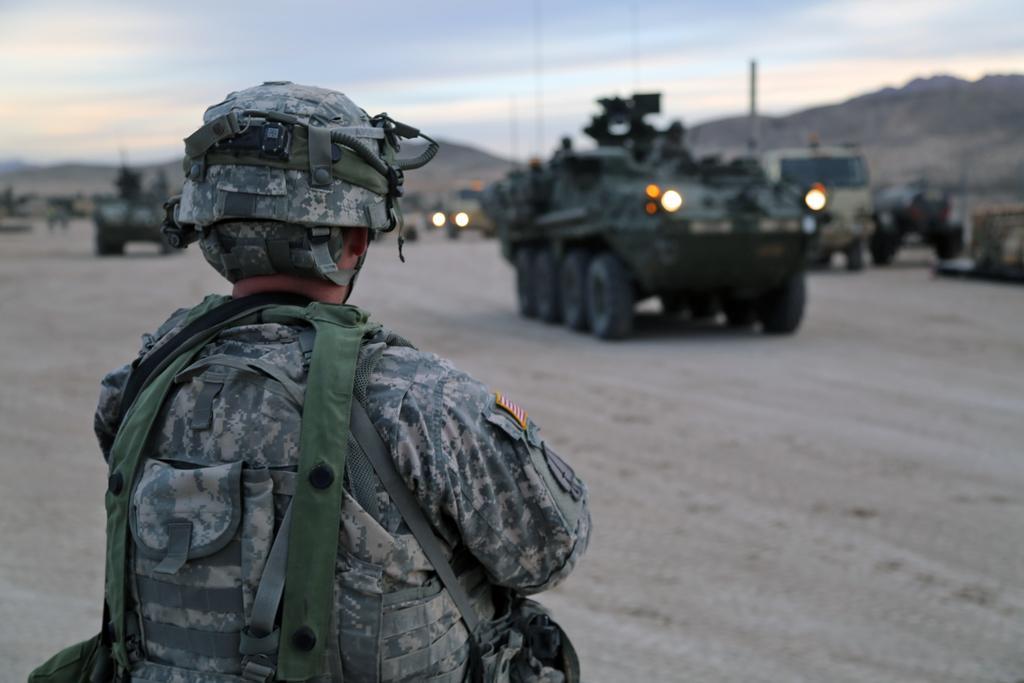In one or two sentences, can you explain what this image depicts? In this picture we can see a man, he wore a helmet, in the background we can find few vehicles. 